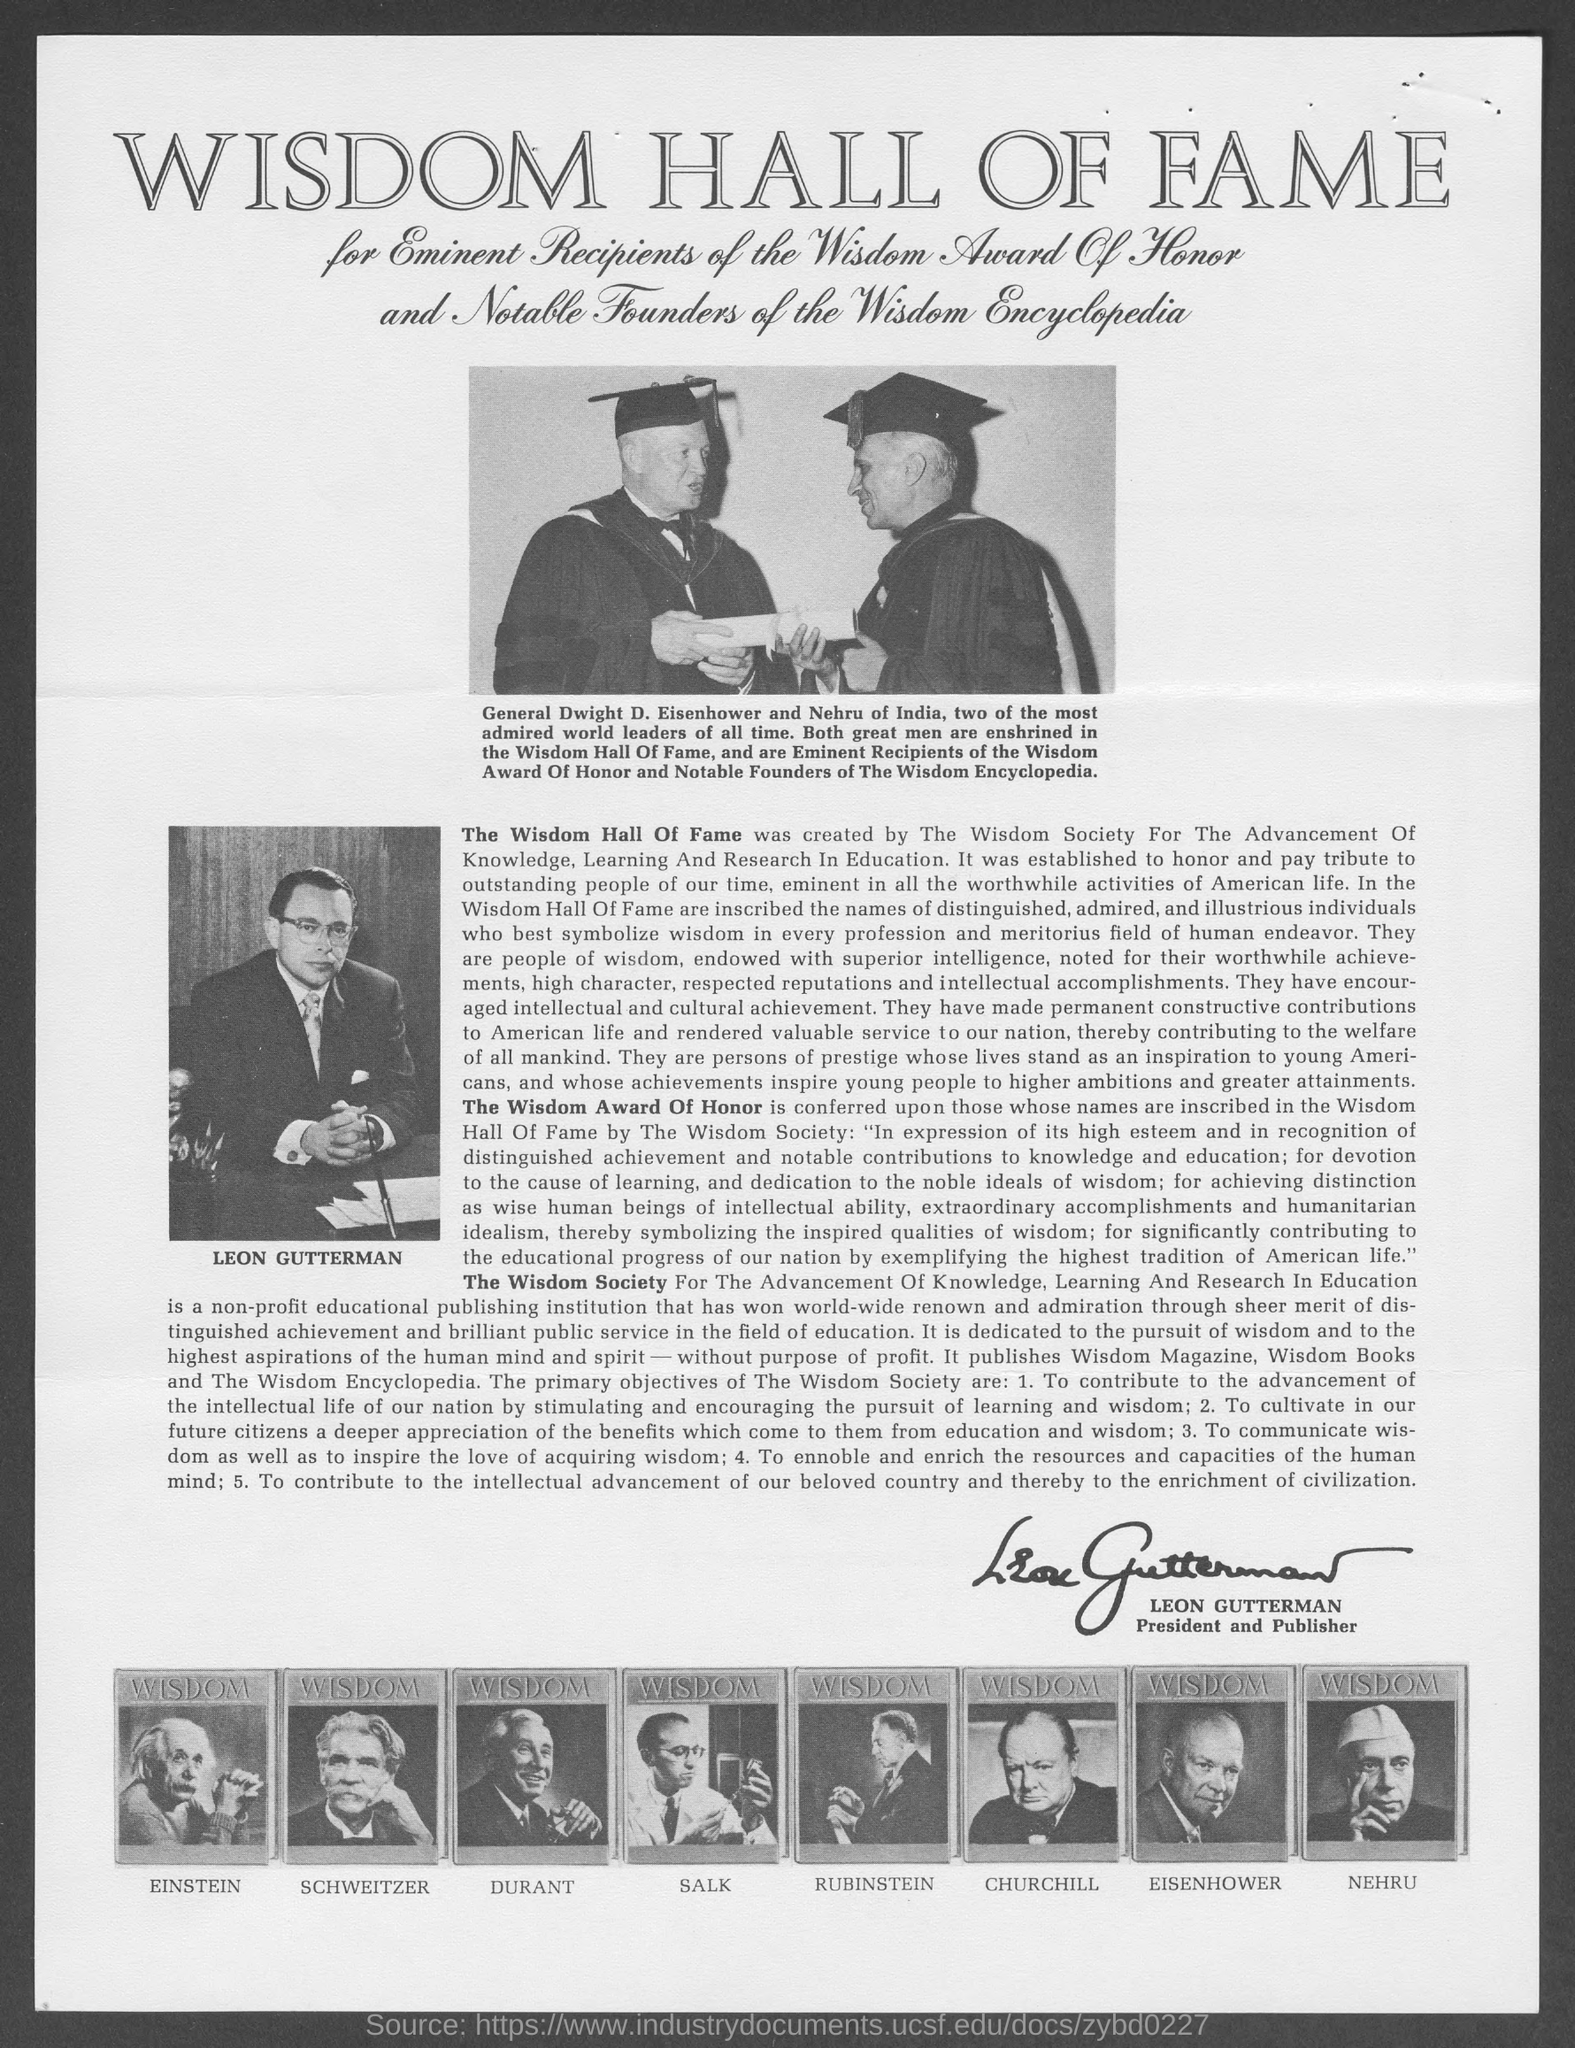Highlight a few significant elements in this photo. Einstein's picture appears as the first photo in the row of pictures located at the bottom of the document. The signature on the document belongs to Leon Gutterman. The current president and publisher of the Wisdom Society is Leon Gutterman. The Wisdom Award of Honor is the name of the award mentioned in this document. The heading of this document is 'Wisdom Hall of Fame.' 